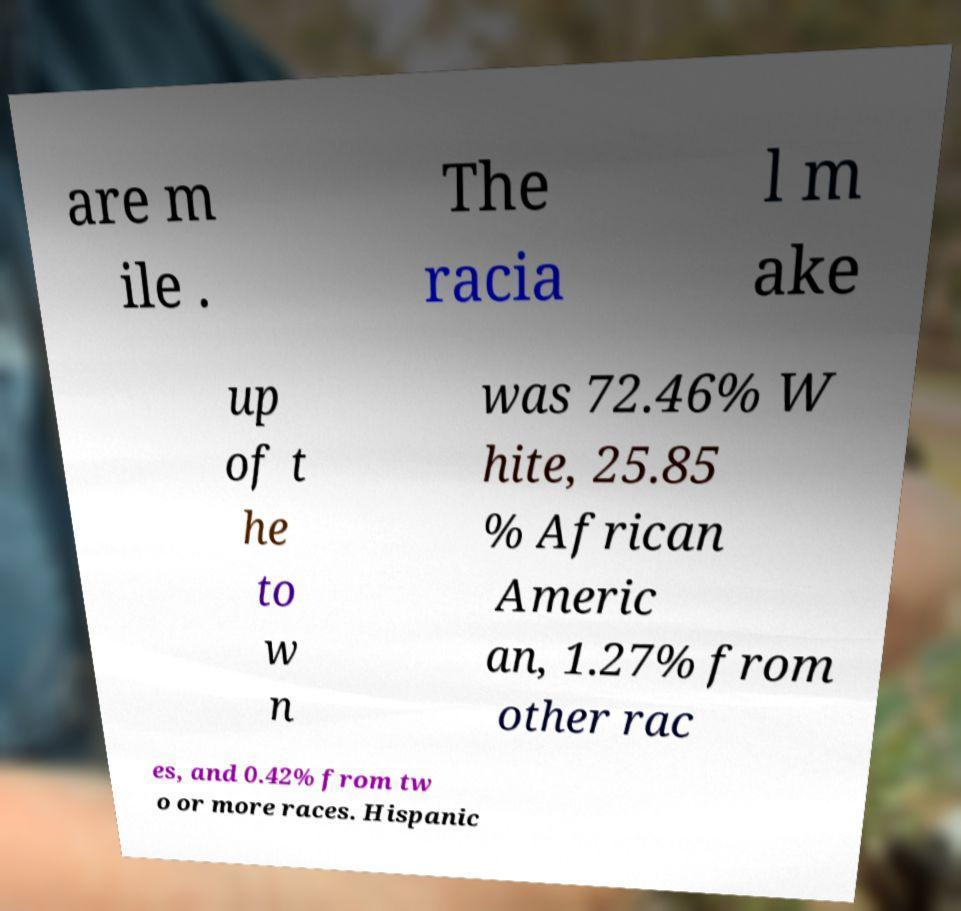Please read and relay the text visible in this image. What does it say? are m ile . The racia l m ake up of t he to w n was 72.46% W hite, 25.85 % African Americ an, 1.27% from other rac es, and 0.42% from tw o or more races. Hispanic 